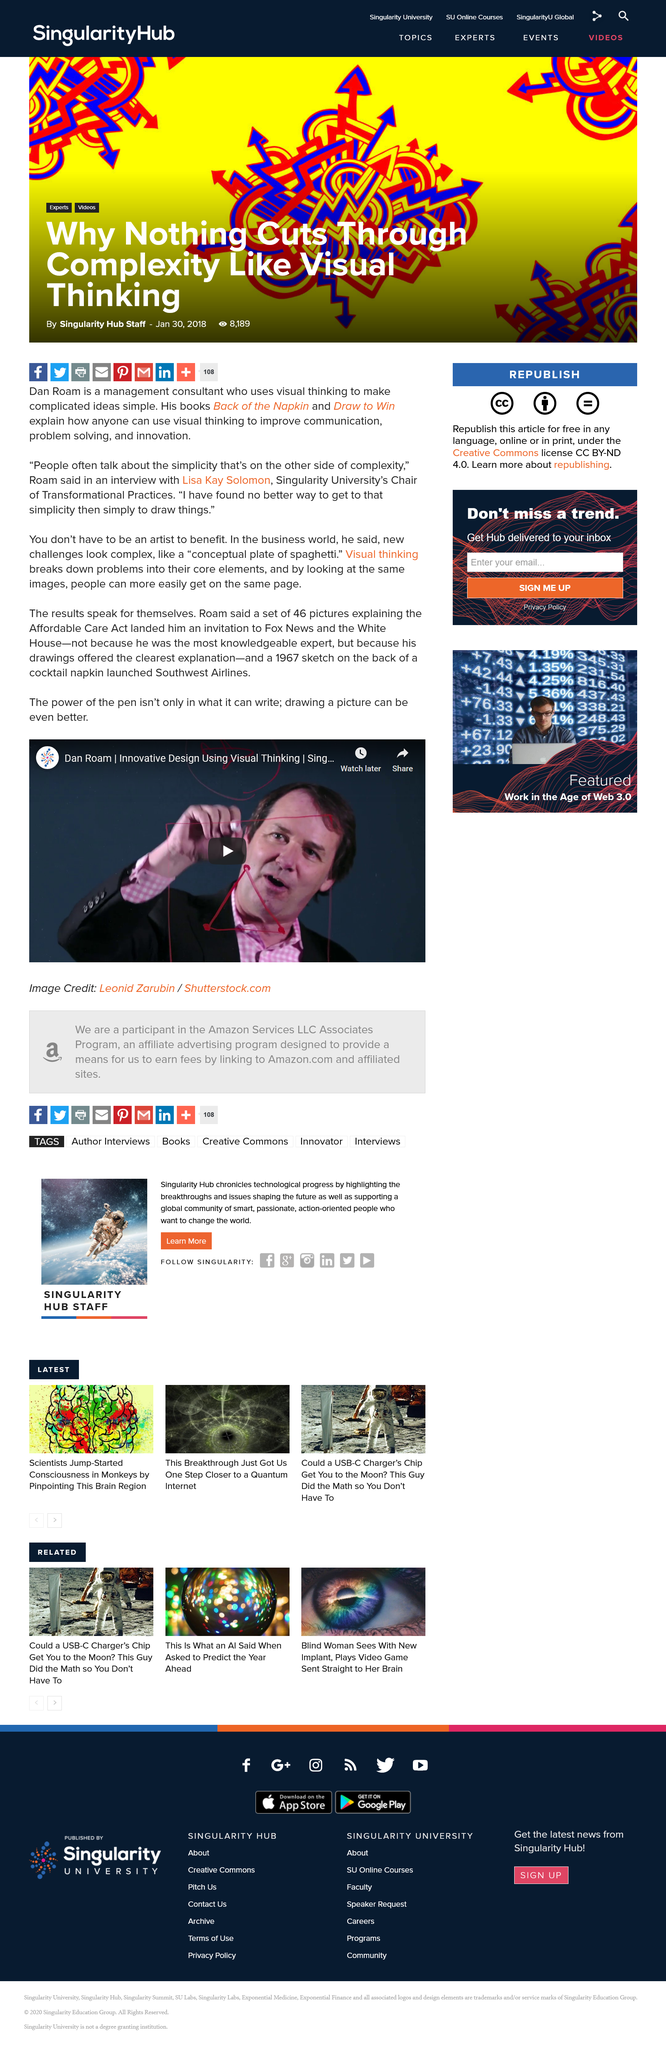Outline some significant characteristics in this image. Roam created 46 photos that explained the Affordable Care Act. Roam was not the most knowledgeable expert among all the experts present. The success of Southwest Airlines was sparked by a 1967 sketch on the back of a cocktail napkin, demonstrating that the power of visual communication can be more impactful than written words. 